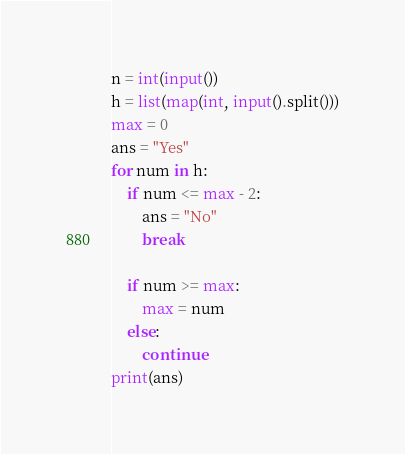Convert code to text. <code><loc_0><loc_0><loc_500><loc_500><_Python_>n = int(input())
h = list(map(int, input().split()))
max = 0
ans = "Yes"
for num in h:
    if num <= max - 2:
        ans = "No"
        break

    if num >= max:
        max = num
    else:
        continue
print(ans)</code> 